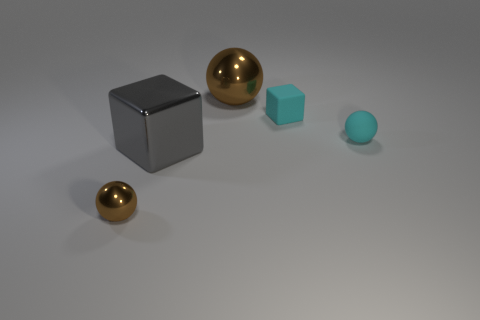Subtract all yellow cubes. How many brown spheres are left? 2 Add 3 tiny spheres. How many objects exist? 8 Subtract all spheres. How many objects are left? 2 Add 2 matte blocks. How many matte blocks are left? 3 Add 4 cyan cubes. How many cyan cubes exist? 5 Subtract 0 brown cylinders. How many objects are left? 5 Subtract all small rubber spheres. Subtract all cyan things. How many objects are left? 2 